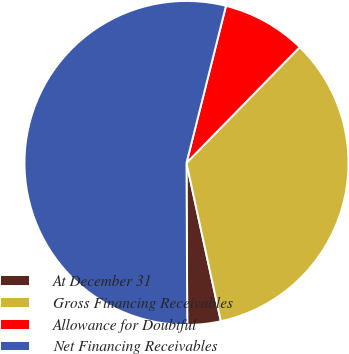<chart> <loc_0><loc_0><loc_500><loc_500><pie_chart><fcel>At December 31<fcel>Gross Financing Receivables<fcel>Allowance for Doubtful<fcel>Net Financing Receivables<nl><fcel>3.33%<fcel>34.28%<fcel>8.4%<fcel>54.0%<nl></chart> 